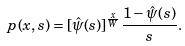Convert formula to latex. <formula><loc_0><loc_0><loc_500><loc_500>p ( x , s ) = [ \hat { \psi } ( s ) ] ^ { \frac { x } { W } } \frac { 1 - \hat { \psi } ( s ) } { s } .</formula> 